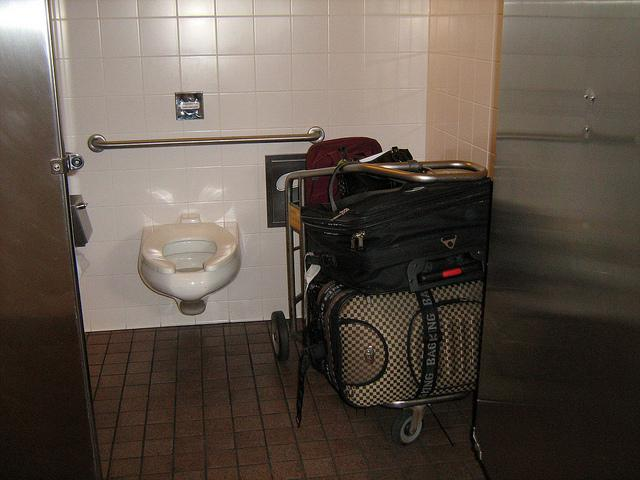Where is this bathroom likely to be found in? airport 